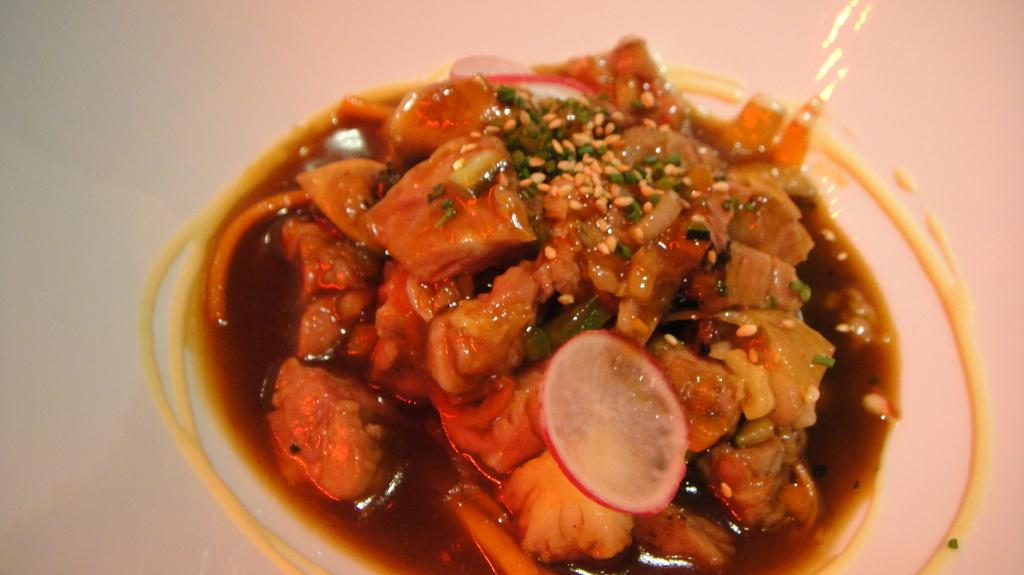What is the main subject of the image? There is a food item in the image. How is the food item contained or presented in the image? The food item is in a white container. What type of face can be seen on the food item in the image? There is no face present on the food item in the image. What type of picture is depicted on the food item in the image? There is no picture present on the food item in the image. What type of curve can be seen on the food item in the image? There is no curve present on the food item in the image. 